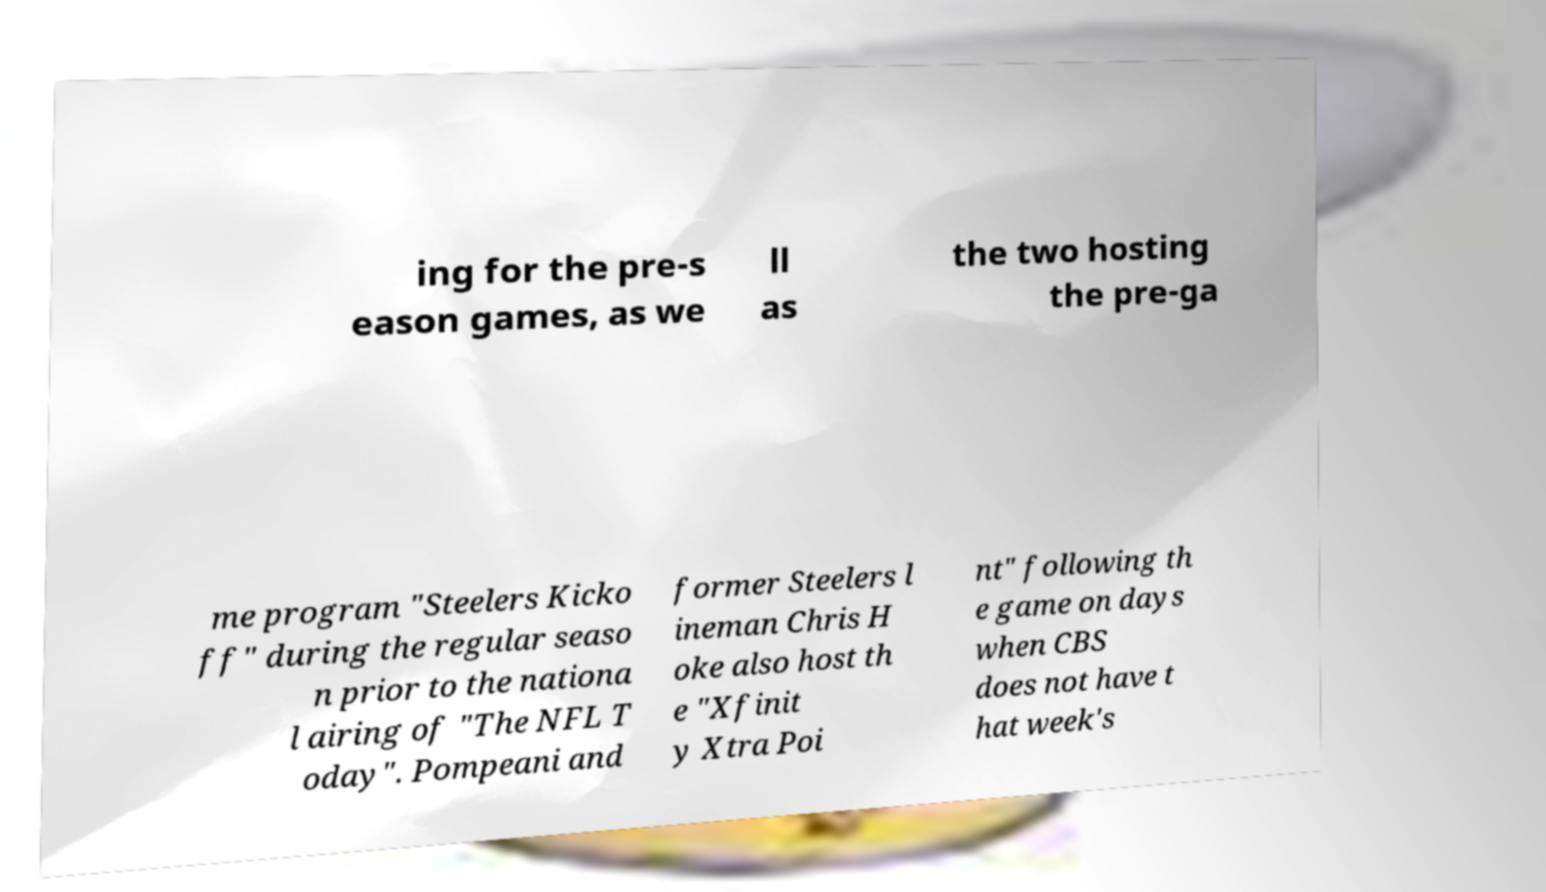Please read and relay the text visible in this image. What does it say? ing for the pre-s eason games, as we ll as the two hosting the pre-ga me program "Steelers Kicko ff" during the regular seaso n prior to the nationa l airing of "The NFL T oday". Pompeani and former Steelers l ineman Chris H oke also host th e "Xfinit y Xtra Poi nt" following th e game on days when CBS does not have t hat week's 